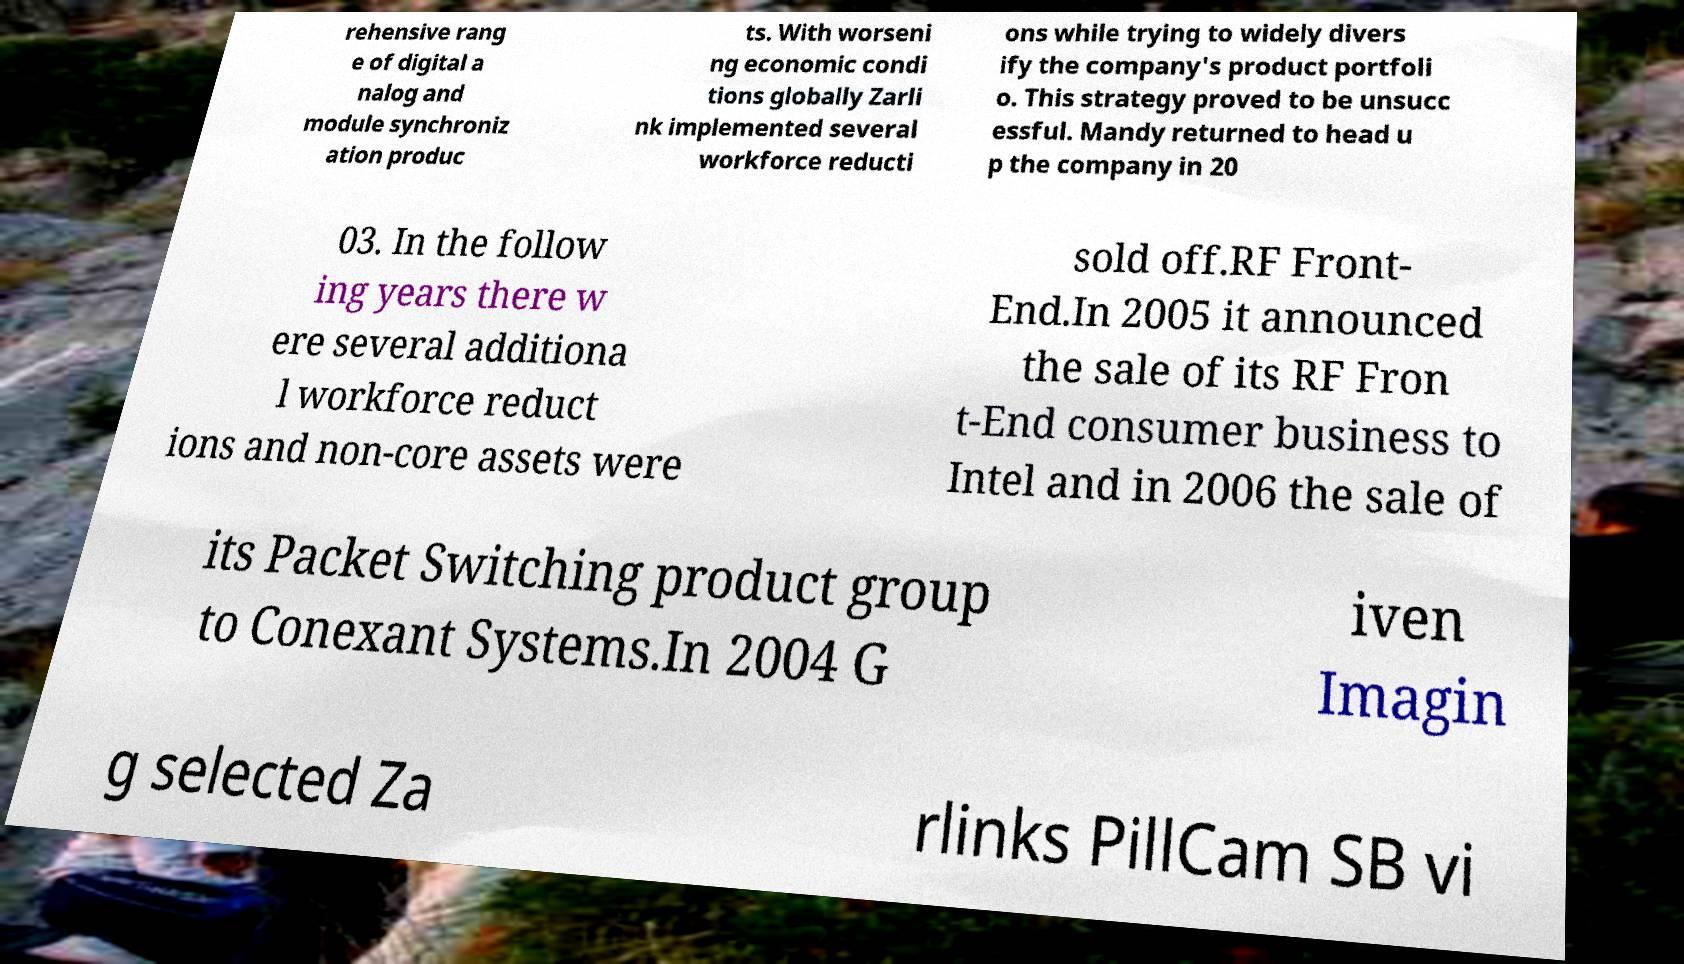Could you assist in decoding the text presented in this image and type it out clearly? rehensive rang e of digital a nalog and module synchroniz ation produc ts. With worseni ng economic condi tions globally Zarli nk implemented several workforce reducti ons while trying to widely divers ify the company's product portfoli o. This strategy proved to be unsucc essful. Mandy returned to head u p the company in 20 03. In the follow ing years there w ere several additiona l workforce reduct ions and non-core assets were sold off.RF Front- End.In 2005 it announced the sale of its RF Fron t-End consumer business to Intel and in 2006 the sale of its Packet Switching product group to Conexant Systems.In 2004 G iven Imagin g selected Za rlinks PillCam SB vi 